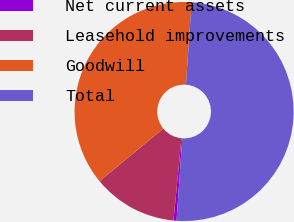Convert chart to OTSL. <chart><loc_0><loc_0><loc_500><loc_500><pie_chart><fcel>Net current assets<fcel>Leasehold improvements<fcel>Goodwill<fcel>Total<nl><fcel>0.45%<fcel>12.49%<fcel>37.06%<fcel>50.0%<nl></chart> 